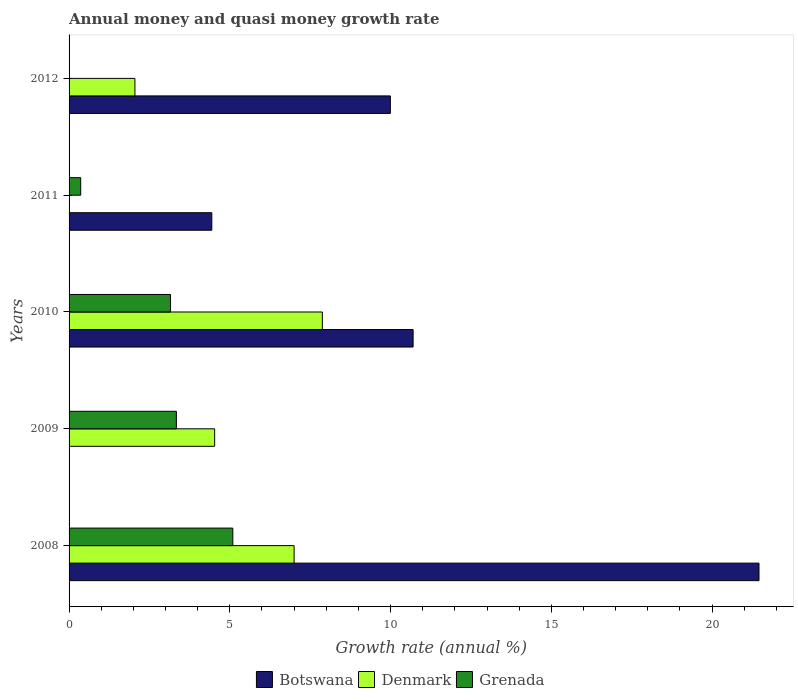In how many cases, is the number of bars for a given year not equal to the number of legend labels?
Provide a short and direct response. 3. What is the growth rate in Denmark in 2012?
Offer a very short reply. 2.05. Across all years, what is the maximum growth rate in Botswana?
Offer a terse response. 21.46. What is the total growth rate in Grenada in the graph?
Offer a very short reply. 11.95. What is the difference between the growth rate in Botswana in 2011 and that in 2012?
Ensure brevity in your answer.  -5.55. What is the difference between the growth rate in Grenada in 2011 and the growth rate in Denmark in 2012?
Your answer should be very brief. -1.69. What is the average growth rate in Botswana per year?
Keep it short and to the point. 9.32. In the year 2012, what is the difference between the growth rate in Botswana and growth rate in Denmark?
Ensure brevity in your answer.  7.95. What is the ratio of the growth rate in Grenada in 2009 to that in 2010?
Keep it short and to the point. 1.06. What is the difference between the highest and the second highest growth rate in Denmark?
Ensure brevity in your answer.  0.88. What is the difference between the highest and the lowest growth rate in Botswana?
Your answer should be very brief. 21.46. In how many years, is the growth rate in Grenada greater than the average growth rate in Grenada taken over all years?
Ensure brevity in your answer.  3. Is the sum of the growth rate in Botswana in 2010 and 2012 greater than the maximum growth rate in Denmark across all years?
Make the answer very short. Yes. Is it the case that in every year, the sum of the growth rate in Botswana and growth rate in Denmark is greater than the growth rate in Grenada?
Provide a succinct answer. Yes. How many bars are there?
Offer a terse response. 12. How many years are there in the graph?
Your answer should be very brief. 5. Does the graph contain any zero values?
Keep it short and to the point. Yes. How many legend labels are there?
Keep it short and to the point. 3. How are the legend labels stacked?
Provide a short and direct response. Horizontal. What is the title of the graph?
Provide a succinct answer. Annual money and quasi money growth rate. What is the label or title of the X-axis?
Offer a very short reply. Growth rate (annual %). What is the label or title of the Y-axis?
Your response must be concise. Years. What is the Growth rate (annual %) in Botswana in 2008?
Offer a very short reply. 21.46. What is the Growth rate (annual %) in Denmark in 2008?
Offer a terse response. 7. What is the Growth rate (annual %) in Grenada in 2008?
Ensure brevity in your answer.  5.09. What is the Growth rate (annual %) of Denmark in 2009?
Provide a succinct answer. 4.53. What is the Growth rate (annual %) of Grenada in 2009?
Provide a succinct answer. 3.34. What is the Growth rate (annual %) in Botswana in 2010?
Your response must be concise. 10.7. What is the Growth rate (annual %) in Denmark in 2010?
Your answer should be very brief. 7.88. What is the Growth rate (annual %) in Grenada in 2010?
Keep it short and to the point. 3.15. What is the Growth rate (annual %) of Botswana in 2011?
Offer a terse response. 4.44. What is the Growth rate (annual %) in Grenada in 2011?
Provide a succinct answer. 0.36. What is the Growth rate (annual %) in Botswana in 2012?
Provide a short and direct response. 9.99. What is the Growth rate (annual %) of Denmark in 2012?
Make the answer very short. 2.05. Across all years, what is the maximum Growth rate (annual %) in Botswana?
Ensure brevity in your answer.  21.46. Across all years, what is the maximum Growth rate (annual %) in Denmark?
Offer a terse response. 7.88. Across all years, what is the maximum Growth rate (annual %) in Grenada?
Provide a short and direct response. 5.09. Across all years, what is the minimum Growth rate (annual %) of Botswana?
Your answer should be very brief. 0. Across all years, what is the minimum Growth rate (annual %) in Grenada?
Your response must be concise. 0. What is the total Growth rate (annual %) in Botswana in the graph?
Offer a very short reply. 46.6. What is the total Growth rate (annual %) in Denmark in the graph?
Your answer should be compact. 21.46. What is the total Growth rate (annual %) in Grenada in the graph?
Your response must be concise. 11.95. What is the difference between the Growth rate (annual %) in Denmark in 2008 and that in 2009?
Provide a short and direct response. 2.47. What is the difference between the Growth rate (annual %) in Grenada in 2008 and that in 2009?
Your answer should be compact. 1.76. What is the difference between the Growth rate (annual %) of Botswana in 2008 and that in 2010?
Offer a very short reply. 10.76. What is the difference between the Growth rate (annual %) of Denmark in 2008 and that in 2010?
Offer a very short reply. -0.88. What is the difference between the Growth rate (annual %) in Grenada in 2008 and that in 2010?
Your answer should be compact. 1.94. What is the difference between the Growth rate (annual %) of Botswana in 2008 and that in 2011?
Provide a succinct answer. 17.02. What is the difference between the Growth rate (annual %) of Grenada in 2008 and that in 2011?
Make the answer very short. 4.73. What is the difference between the Growth rate (annual %) in Botswana in 2008 and that in 2012?
Offer a very short reply. 11.47. What is the difference between the Growth rate (annual %) of Denmark in 2008 and that in 2012?
Offer a terse response. 4.95. What is the difference between the Growth rate (annual %) in Denmark in 2009 and that in 2010?
Offer a very short reply. -3.35. What is the difference between the Growth rate (annual %) of Grenada in 2009 and that in 2010?
Your answer should be compact. 0.18. What is the difference between the Growth rate (annual %) of Grenada in 2009 and that in 2011?
Keep it short and to the point. 2.98. What is the difference between the Growth rate (annual %) in Denmark in 2009 and that in 2012?
Give a very brief answer. 2.48. What is the difference between the Growth rate (annual %) of Botswana in 2010 and that in 2011?
Your answer should be very brief. 6.26. What is the difference between the Growth rate (annual %) of Grenada in 2010 and that in 2011?
Ensure brevity in your answer.  2.79. What is the difference between the Growth rate (annual %) in Botswana in 2010 and that in 2012?
Keep it short and to the point. 0.71. What is the difference between the Growth rate (annual %) in Denmark in 2010 and that in 2012?
Provide a succinct answer. 5.83. What is the difference between the Growth rate (annual %) of Botswana in 2011 and that in 2012?
Offer a very short reply. -5.55. What is the difference between the Growth rate (annual %) of Botswana in 2008 and the Growth rate (annual %) of Denmark in 2009?
Make the answer very short. 16.93. What is the difference between the Growth rate (annual %) of Botswana in 2008 and the Growth rate (annual %) of Grenada in 2009?
Your response must be concise. 18.12. What is the difference between the Growth rate (annual %) of Denmark in 2008 and the Growth rate (annual %) of Grenada in 2009?
Provide a short and direct response. 3.66. What is the difference between the Growth rate (annual %) of Botswana in 2008 and the Growth rate (annual %) of Denmark in 2010?
Make the answer very short. 13.58. What is the difference between the Growth rate (annual %) in Botswana in 2008 and the Growth rate (annual %) in Grenada in 2010?
Ensure brevity in your answer.  18.31. What is the difference between the Growth rate (annual %) of Denmark in 2008 and the Growth rate (annual %) of Grenada in 2010?
Ensure brevity in your answer.  3.85. What is the difference between the Growth rate (annual %) in Botswana in 2008 and the Growth rate (annual %) in Grenada in 2011?
Your answer should be very brief. 21.1. What is the difference between the Growth rate (annual %) of Denmark in 2008 and the Growth rate (annual %) of Grenada in 2011?
Offer a terse response. 6.64. What is the difference between the Growth rate (annual %) in Botswana in 2008 and the Growth rate (annual %) in Denmark in 2012?
Offer a very short reply. 19.41. What is the difference between the Growth rate (annual %) of Denmark in 2009 and the Growth rate (annual %) of Grenada in 2010?
Provide a succinct answer. 1.37. What is the difference between the Growth rate (annual %) of Denmark in 2009 and the Growth rate (annual %) of Grenada in 2011?
Your response must be concise. 4.17. What is the difference between the Growth rate (annual %) of Botswana in 2010 and the Growth rate (annual %) of Grenada in 2011?
Make the answer very short. 10.34. What is the difference between the Growth rate (annual %) of Denmark in 2010 and the Growth rate (annual %) of Grenada in 2011?
Your response must be concise. 7.52. What is the difference between the Growth rate (annual %) of Botswana in 2010 and the Growth rate (annual %) of Denmark in 2012?
Make the answer very short. 8.65. What is the difference between the Growth rate (annual %) of Botswana in 2011 and the Growth rate (annual %) of Denmark in 2012?
Ensure brevity in your answer.  2.39. What is the average Growth rate (annual %) in Botswana per year?
Your response must be concise. 9.32. What is the average Growth rate (annual %) of Denmark per year?
Give a very brief answer. 4.29. What is the average Growth rate (annual %) in Grenada per year?
Your answer should be compact. 2.39. In the year 2008, what is the difference between the Growth rate (annual %) in Botswana and Growth rate (annual %) in Denmark?
Make the answer very short. 14.46. In the year 2008, what is the difference between the Growth rate (annual %) of Botswana and Growth rate (annual %) of Grenada?
Keep it short and to the point. 16.37. In the year 2008, what is the difference between the Growth rate (annual %) of Denmark and Growth rate (annual %) of Grenada?
Offer a very short reply. 1.91. In the year 2009, what is the difference between the Growth rate (annual %) in Denmark and Growth rate (annual %) in Grenada?
Your answer should be compact. 1.19. In the year 2010, what is the difference between the Growth rate (annual %) of Botswana and Growth rate (annual %) of Denmark?
Ensure brevity in your answer.  2.82. In the year 2010, what is the difference between the Growth rate (annual %) of Botswana and Growth rate (annual %) of Grenada?
Your response must be concise. 7.55. In the year 2010, what is the difference between the Growth rate (annual %) of Denmark and Growth rate (annual %) of Grenada?
Your answer should be very brief. 4.72. In the year 2011, what is the difference between the Growth rate (annual %) of Botswana and Growth rate (annual %) of Grenada?
Your answer should be very brief. 4.08. In the year 2012, what is the difference between the Growth rate (annual %) in Botswana and Growth rate (annual %) in Denmark?
Offer a terse response. 7.95. What is the ratio of the Growth rate (annual %) of Denmark in 2008 to that in 2009?
Provide a succinct answer. 1.55. What is the ratio of the Growth rate (annual %) in Grenada in 2008 to that in 2009?
Your answer should be compact. 1.53. What is the ratio of the Growth rate (annual %) of Botswana in 2008 to that in 2010?
Give a very brief answer. 2.01. What is the ratio of the Growth rate (annual %) of Denmark in 2008 to that in 2010?
Offer a very short reply. 0.89. What is the ratio of the Growth rate (annual %) of Grenada in 2008 to that in 2010?
Provide a short and direct response. 1.61. What is the ratio of the Growth rate (annual %) of Botswana in 2008 to that in 2011?
Keep it short and to the point. 4.83. What is the ratio of the Growth rate (annual %) in Grenada in 2008 to that in 2011?
Give a very brief answer. 14.07. What is the ratio of the Growth rate (annual %) in Botswana in 2008 to that in 2012?
Provide a succinct answer. 2.15. What is the ratio of the Growth rate (annual %) of Denmark in 2008 to that in 2012?
Ensure brevity in your answer.  3.42. What is the ratio of the Growth rate (annual %) in Denmark in 2009 to that in 2010?
Provide a succinct answer. 0.57. What is the ratio of the Growth rate (annual %) in Grenada in 2009 to that in 2010?
Offer a terse response. 1.06. What is the ratio of the Growth rate (annual %) in Grenada in 2009 to that in 2011?
Offer a very short reply. 9.22. What is the ratio of the Growth rate (annual %) in Denmark in 2009 to that in 2012?
Give a very brief answer. 2.21. What is the ratio of the Growth rate (annual %) in Botswana in 2010 to that in 2011?
Your answer should be very brief. 2.41. What is the ratio of the Growth rate (annual %) of Grenada in 2010 to that in 2011?
Give a very brief answer. 8.72. What is the ratio of the Growth rate (annual %) in Botswana in 2010 to that in 2012?
Your answer should be compact. 1.07. What is the ratio of the Growth rate (annual %) in Denmark in 2010 to that in 2012?
Make the answer very short. 3.85. What is the ratio of the Growth rate (annual %) in Botswana in 2011 to that in 2012?
Your answer should be compact. 0.44. What is the difference between the highest and the second highest Growth rate (annual %) in Botswana?
Offer a terse response. 10.76. What is the difference between the highest and the second highest Growth rate (annual %) in Denmark?
Keep it short and to the point. 0.88. What is the difference between the highest and the second highest Growth rate (annual %) of Grenada?
Offer a terse response. 1.76. What is the difference between the highest and the lowest Growth rate (annual %) of Botswana?
Provide a short and direct response. 21.46. What is the difference between the highest and the lowest Growth rate (annual %) in Denmark?
Your response must be concise. 7.88. What is the difference between the highest and the lowest Growth rate (annual %) of Grenada?
Provide a succinct answer. 5.09. 